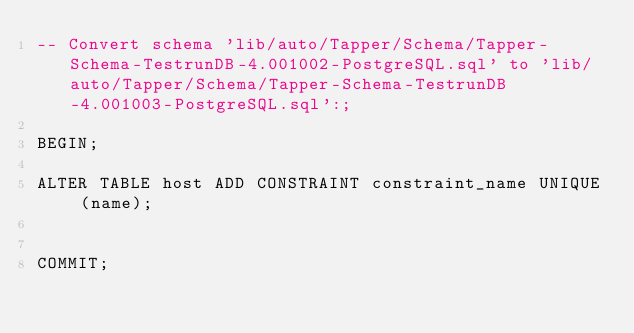Convert code to text. <code><loc_0><loc_0><loc_500><loc_500><_SQL_>-- Convert schema 'lib/auto/Tapper/Schema/Tapper-Schema-TestrunDB-4.001002-PostgreSQL.sql' to 'lib/auto/Tapper/Schema/Tapper-Schema-TestrunDB-4.001003-PostgreSQL.sql':;

BEGIN;

ALTER TABLE host ADD CONSTRAINT constraint_name UNIQUE (name);


COMMIT;

</code> 